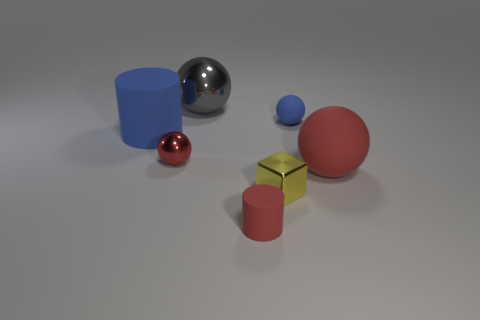Is there anything else that has the same shape as the gray shiny thing?
Provide a succinct answer. Yes. Do the yellow object and the big red matte object have the same shape?
Provide a short and direct response. No. Is the number of tiny shiny objects to the right of the yellow block the same as the number of tiny blue balls that are to the left of the big blue rubber thing?
Keep it short and to the point. Yes. How many other objects are the same material as the large gray thing?
Provide a short and direct response. 2. How many big objects are either gray shiny spheres or red shiny things?
Provide a short and direct response. 1. Are there the same number of big matte things that are left of the big blue rubber object and red spheres?
Offer a very short reply. No. Is there a red object to the left of the tiny ball on the right side of the gray shiny sphere?
Make the answer very short. Yes. How many other things are there of the same color as the small rubber sphere?
Provide a short and direct response. 1. What color is the small rubber cylinder?
Provide a short and direct response. Red. There is a red object that is right of the big gray shiny ball and on the left side of the tiny blue ball; what size is it?
Your answer should be very brief. Small. 